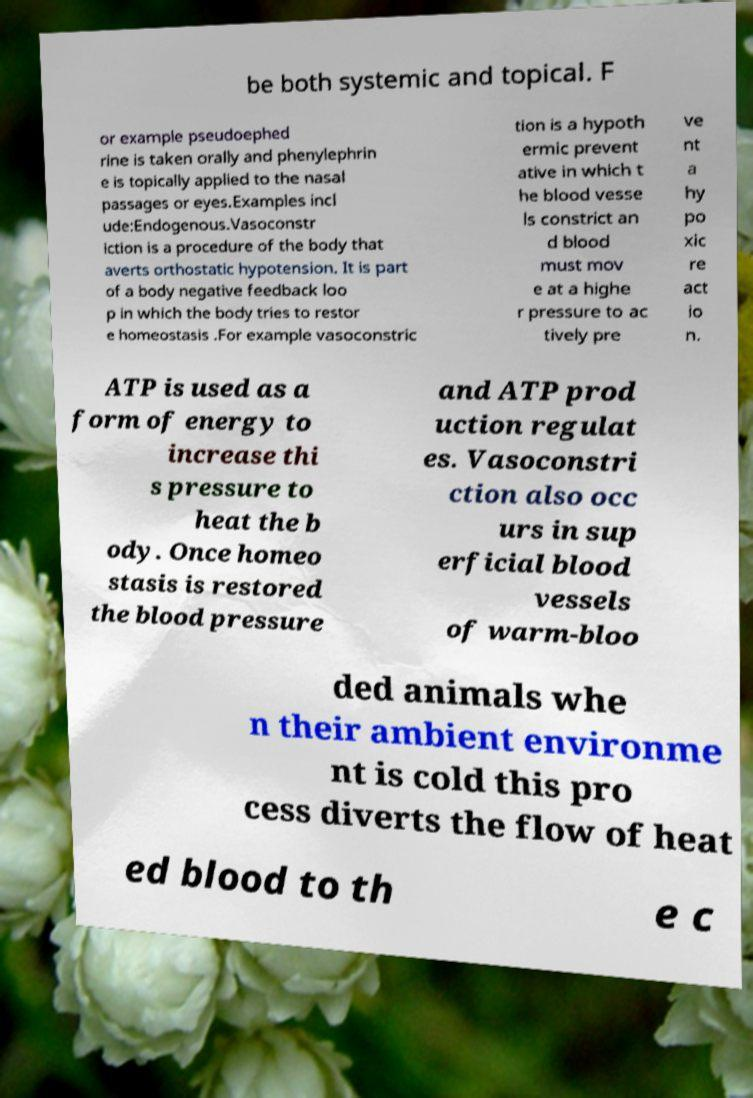Please identify and transcribe the text found in this image. be both systemic and topical. F or example pseudoephed rine is taken orally and phenylephrin e is topically applied to the nasal passages or eyes.Examples incl ude:Endogenous.Vasoconstr iction is a procedure of the body that averts orthostatic hypotension. It is part of a body negative feedback loo p in which the body tries to restor e homeostasis .For example vasoconstric tion is a hypoth ermic prevent ative in which t he blood vesse ls constrict an d blood must mov e at a highe r pressure to ac tively pre ve nt a hy po xic re act io n. ATP is used as a form of energy to increase thi s pressure to heat the b ody. Once homeo stasis is restored the blood pressure and ATP prod uction regulat es. Vasoconstri ction also occ urs in sup erficial blood vessels of warm-bloo ded animals whe n their ambient environme nt is cold this pro cess diverts the flow of heat ed blood to th e c 